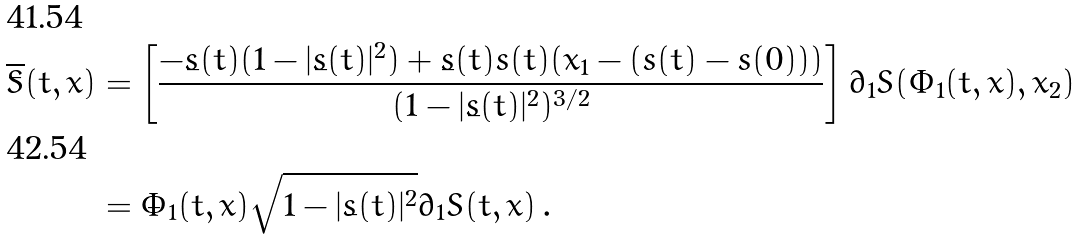<formula> <loc_0><loc_0><loc_500><loc_500>\dot { \overline { S } } ( t , x ) & = \left [ \frac { - \dot { s } ( t ) ( 1 - | \dot { s } ( t ) | ^ { 2 } ) + \dot { s } ( t ) \ddot { s } ( t ) ( x _ { 1 } - ( s ( t ) - s ( 0 ) ) ) } { ( 1 - | \dot { s } ( t ) | ^ { 2 } ) ^ { 3 / 2 } } \right ] { \partial _ { 1 } } S ( \Phi _ { 1 } ( t , x ) , x _ { 2 } ) \\ & = \dot { \Phi } _ { 1 } ( t , x ) \sqrt { 1 - | \dot { s } ( t ) | ^ { 2 } } { \partial _ { 1 } } \bar { S } ( t , x ) \, .</formula> 